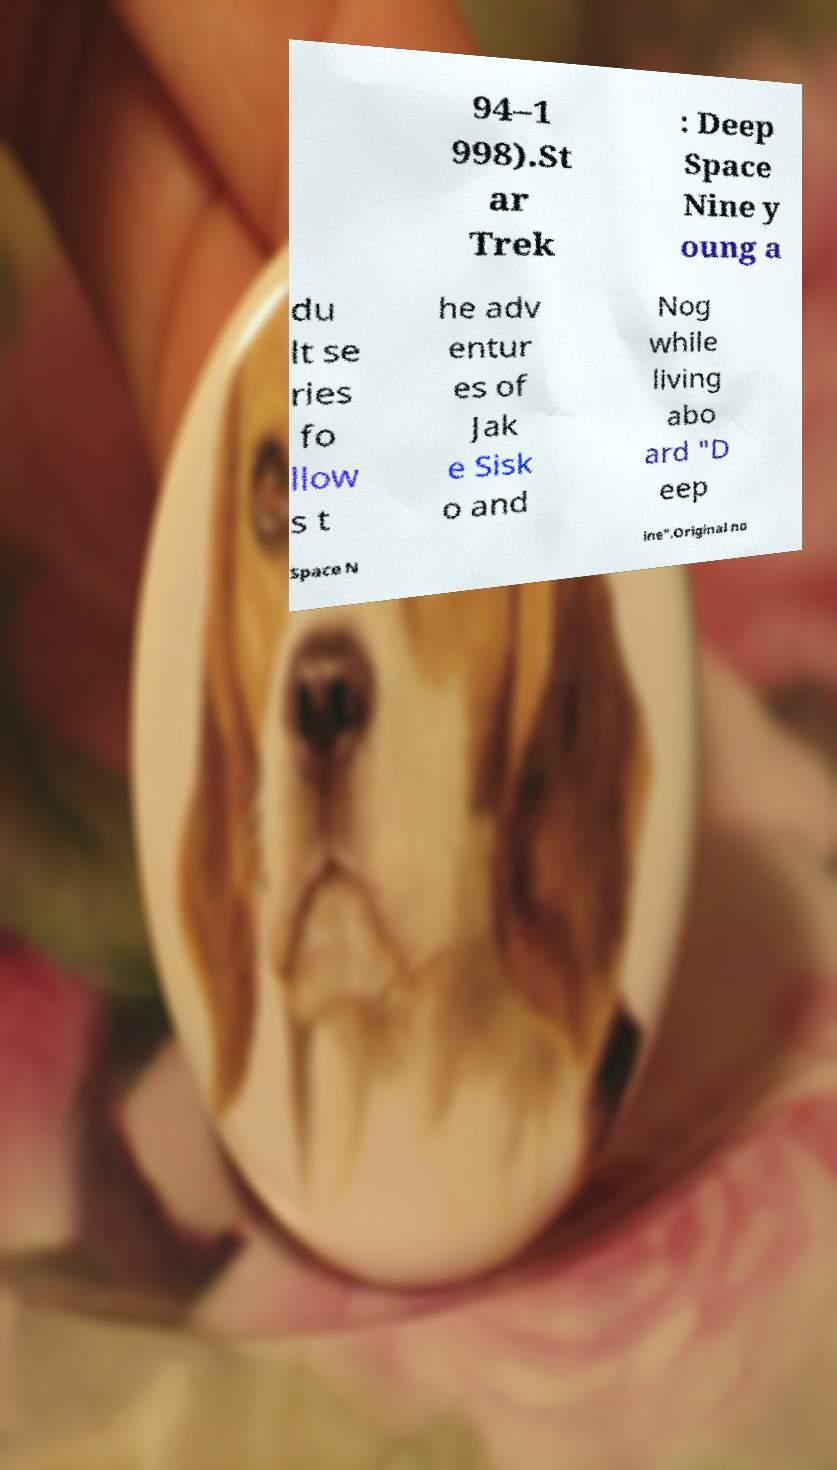Could you extract and type out the text from this image? 94–1 998).St ar Trek : Deep Space Nine y oung a du lt se ries fo llow s t he adv entur es of Jak e Sisk o and Nog while living abo ard "D eep Space N ine".Original no 